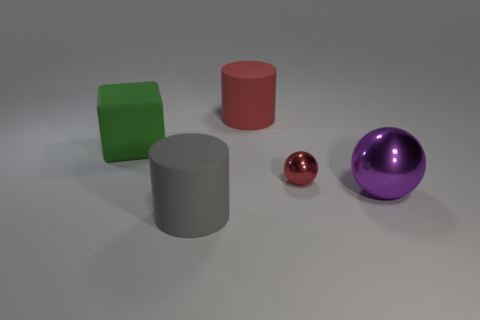How many rubber objects are cubes or purple spheres?
Offer a very short reply. 1. How many other objects are there of the same shape as the purple metal thing?
Keep it short and to the point. 1. Are there more gray matte cylinders than red things?
Keep it short and to the point. No. What is the size of the matte cylinder that is behind the cylinder in front of the rubber cylinder behind the tiny red metallic sphere?
Your answer should be very brief. Large. There is a cylinder that is in front of the purple sphere; what is its size?
Keep it short and to the point. Large. What number of objects are either red rubber blocks or objects that are in front of the big purple object?
Offer a very short reply. 1. What number of other things are the same size as the gray cylinder?
Give a very brief answer. 3. What material is the other object that is the same shape as the gray thing?
Offer a very short reply. Rubber. Is the number of large green matte blocks right of the big green matte thing greater than the number of matte things?
Give a very brief answer. No. Are there any other things of the same color as the large metallic sphere?
Provide a succinct answer. No. 